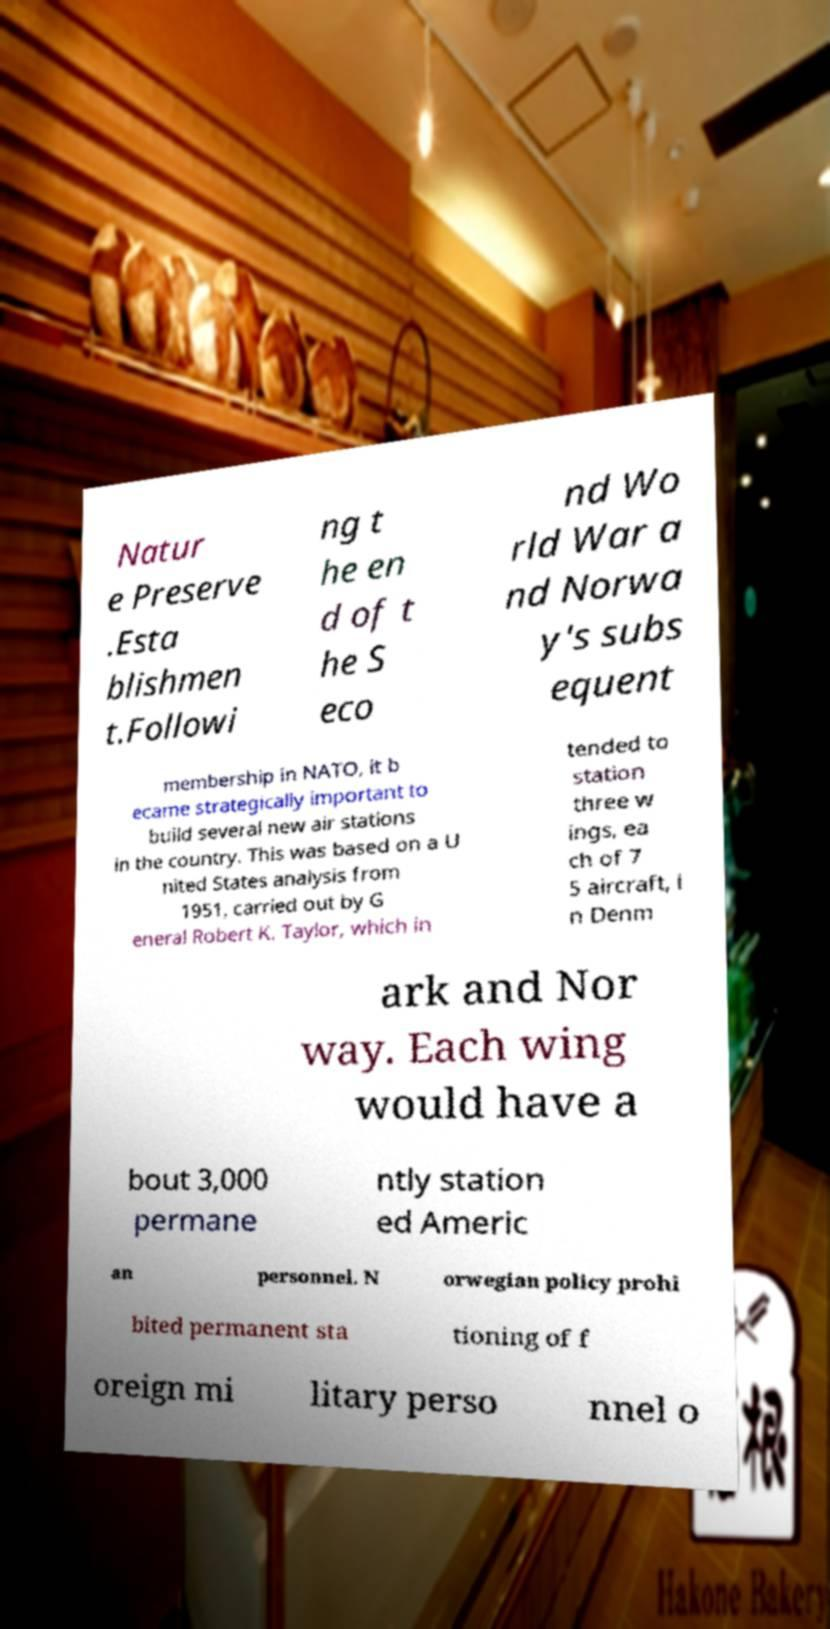Could you assist in decoding the text presented in this image and type it out clearly? Natur e Preserve .Esta blishmen t.Followi ng t he en d of t he S eco nd Wo rld War a nd Norwa y's subs equent membership in NATO, it b ecame strategically important to build several new air stations in the country. This was based on a U nited States analysis from 1951, carried out by G eneral Robert K. Taylor, which in tended to station three w ings, ea ch of 7 5 aircraft, i n Denm ark and Nor way. Each wing would have a bout 3,000 permane ntly station ed Americ an personnel. N orwegian policy prohi bited permanent sta tioning of f oreign mi litary perso nnel o 